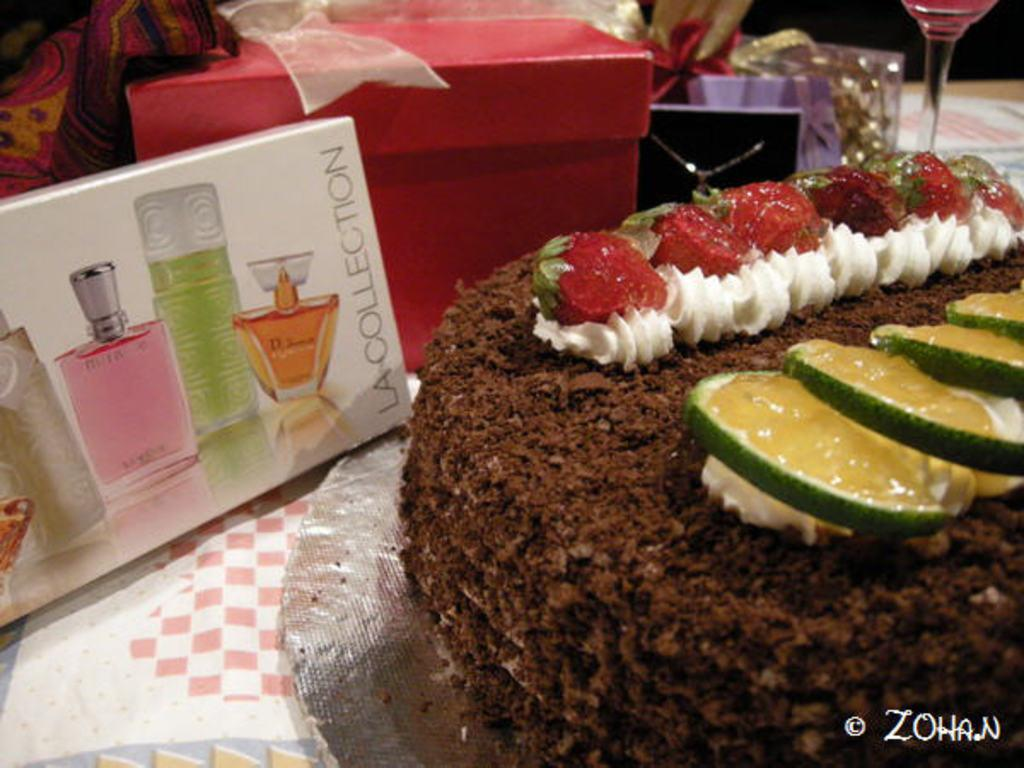<image>
Give a short and clear explanation of the subsequent image. A box of LaCollection perfume, cake, and presents are on a table. 